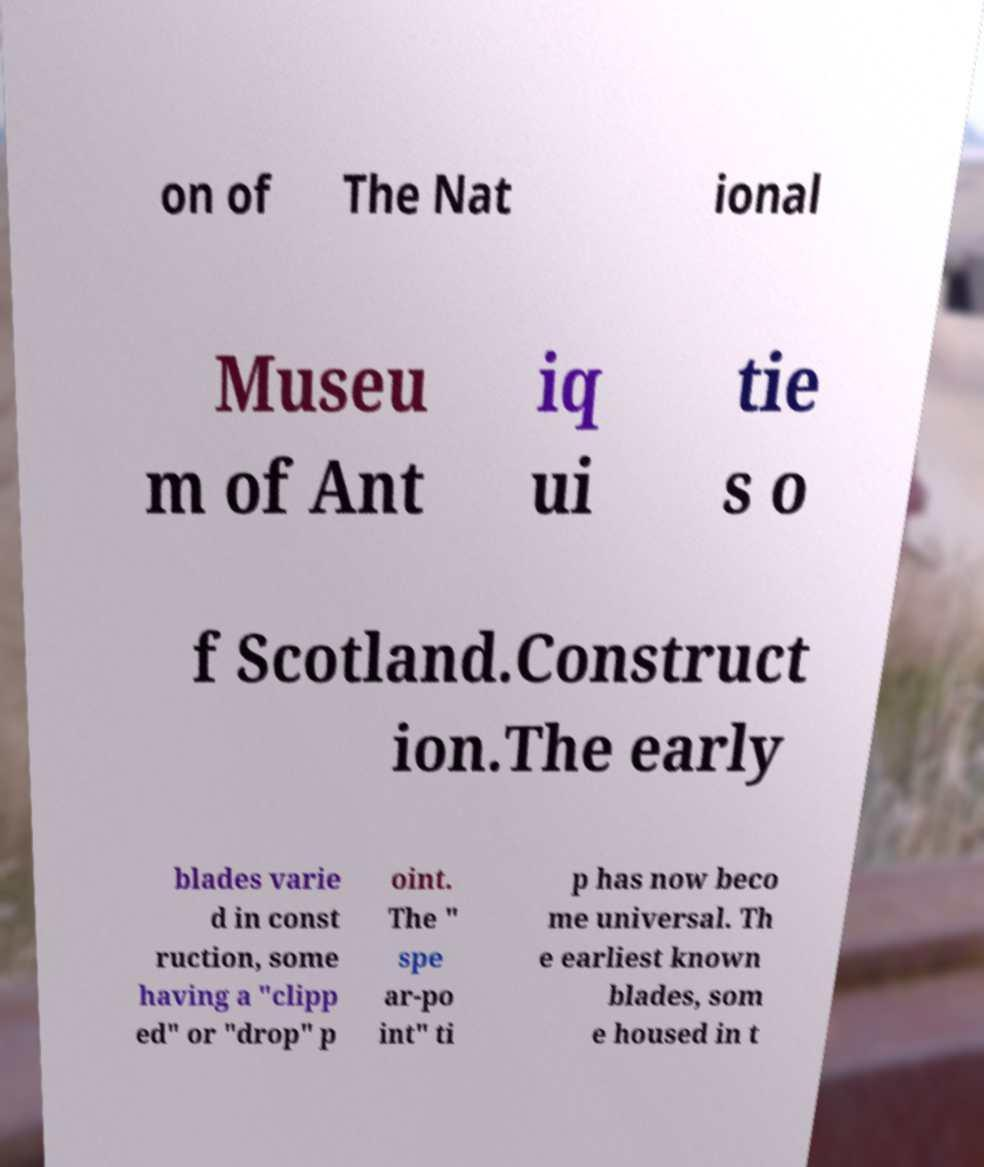Can you accurately transcribe the text from the provided image for me? on of The Nat ional Museu m of Ant iq ui tie s o f Scotland.Construct ion.The early blades varie d in const ruction, some having a "clipp ed" or "drop" p oint. The " spe ar-po int" ti p has now beco me universal. Th e earliest known blades, som e housed in t 